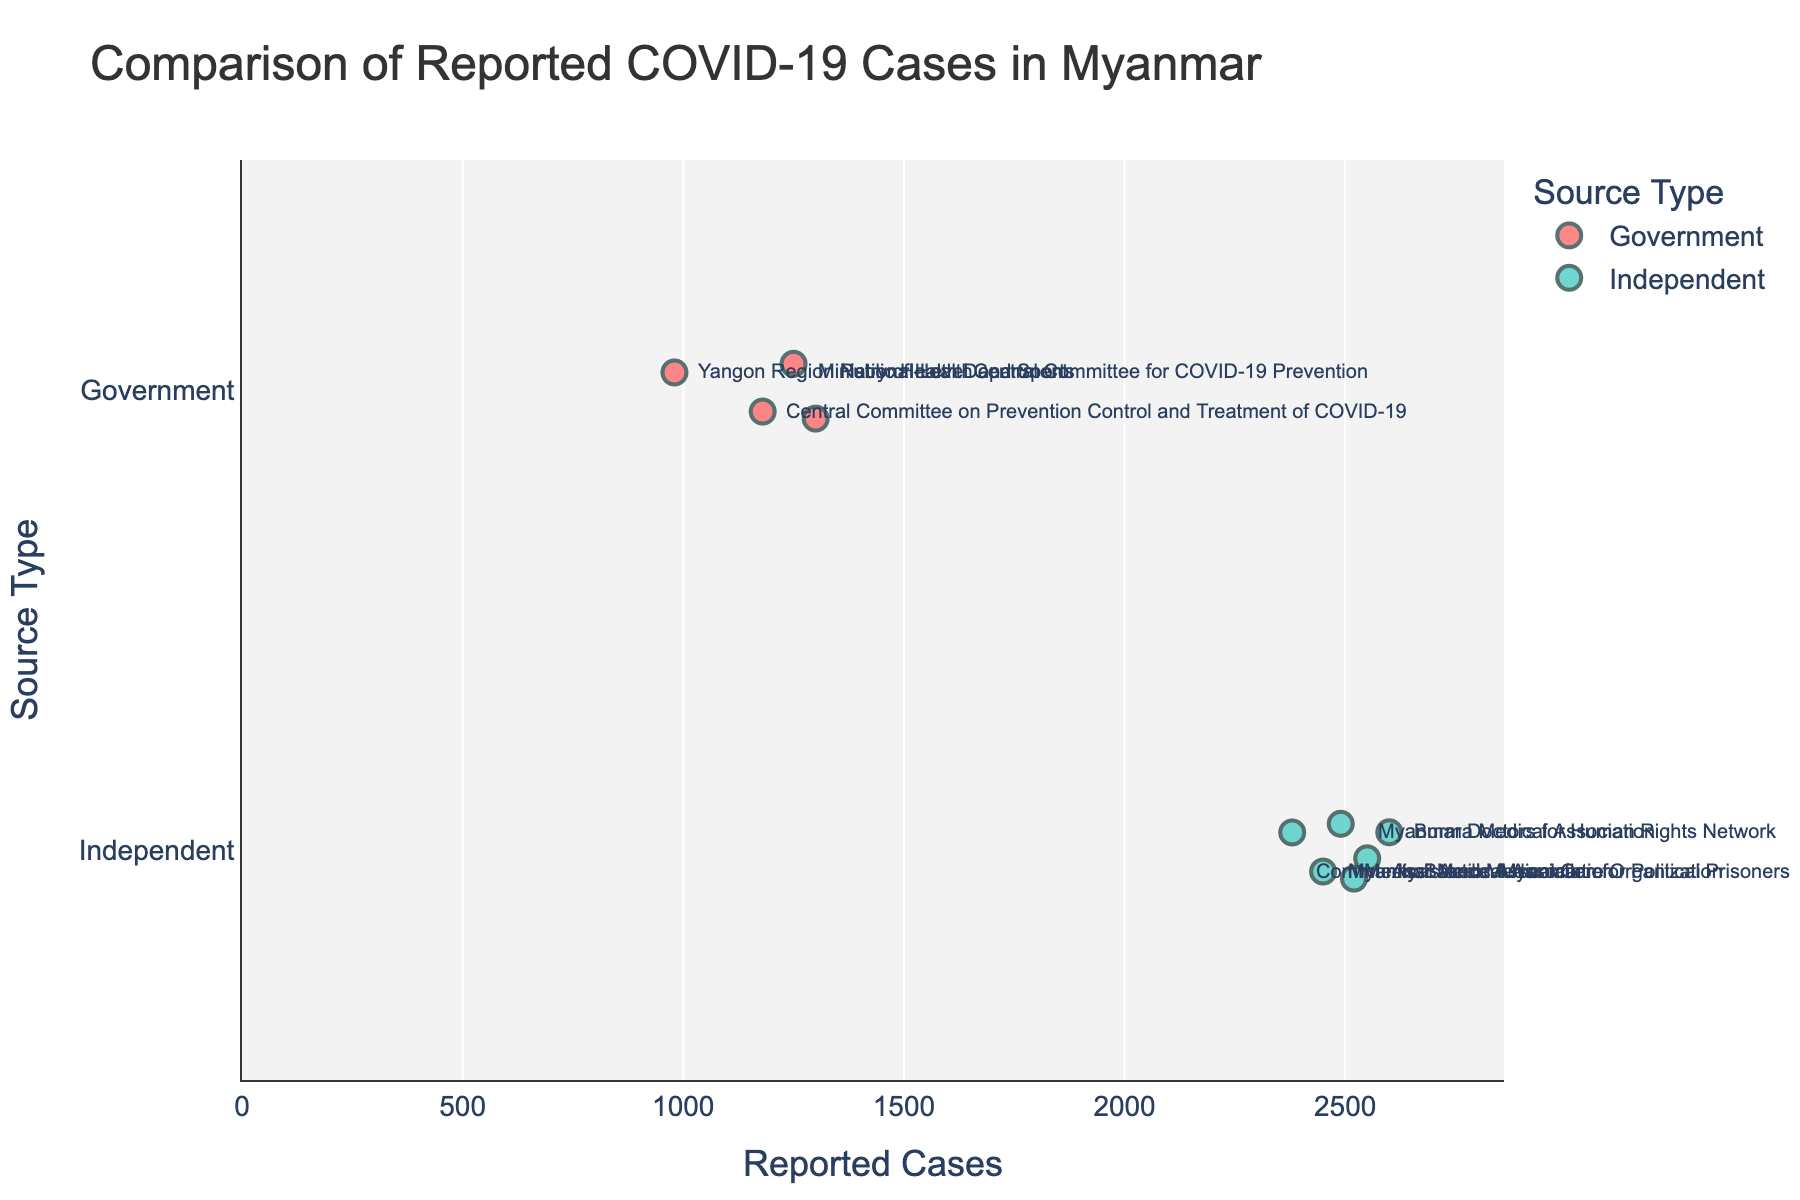Which type of source reports the lower range of COVID-19 cases? The figure shows colored dots for both Government and Independent sources. The Government sources have the lowest reported cases, as indicated by the dots on the left side, ranging from 980 to 1300.
Answer: Government How many independent organizations are included in the figure? By counting the number of data points associated with Independent sources, we see there are 6 dots labeled with different organizations.
Answer: 6 What is the reported case count for the Ministry of Health and Sports? The dot labeled 'Ministry of Health and Sports' is located at 1250 on the x-axis.
Answer: 1250 Which organization reports the highest number of COVID-19 cases? The dot farthest to the right represents the highest reported cases, labeled 'Burma Medical Association,' with 2600 cases.
Answer: Burma Medical Association What is the difference between the highest and lowest reported cases from government sources? The highest reported cases by a Government source is 1300, and the lowest is 980. Subtracting the smallest value from the largest gives 1300 - 980.
Answer: 320 Which type of source has more variability in reported cases? Comparing the spread of dots along the x-axis, Independent sources show a wider spread (from 2380 to 2600) than Government sources (from 980 to 1300), indicating higher variability.
Answer: Independent Are there any Independent organizations that report fewer cases than the highest reporting Government source? The highest reported cases by a Government source are 1300. All dots for Independent sources are to the right of this value, meaning no Independent organization reports fewer cases than 1300.
Answer: No What is the average reported cases among the Independent organizations? Adding the reported cases of all Independent organizations (2450 + 2600 + 2380 + 2520 + 2490 + 2550) and dividing by the number of organizations (6) gives the average.
Answer: 2498.33 Which Government organization reports the fewest COVID-19 cases? The dot farthest to the left among Government sources is labeled 'Yangon Region Public Health Department' with 980 cases.
Answer: Yangon Region Public Health Department How many organizations report COVID-19 cases higher than 2500? Identifying the dots positioned right of 2500 on the x-axis, we find that 'Burma Medical Association,' 'Myanmar Doctors for Human Rights Network,' 'Assistance Association for Political Prisoners,' and 'Medical Action Myanmar' report cases higher than 2500.
Answer: 4 